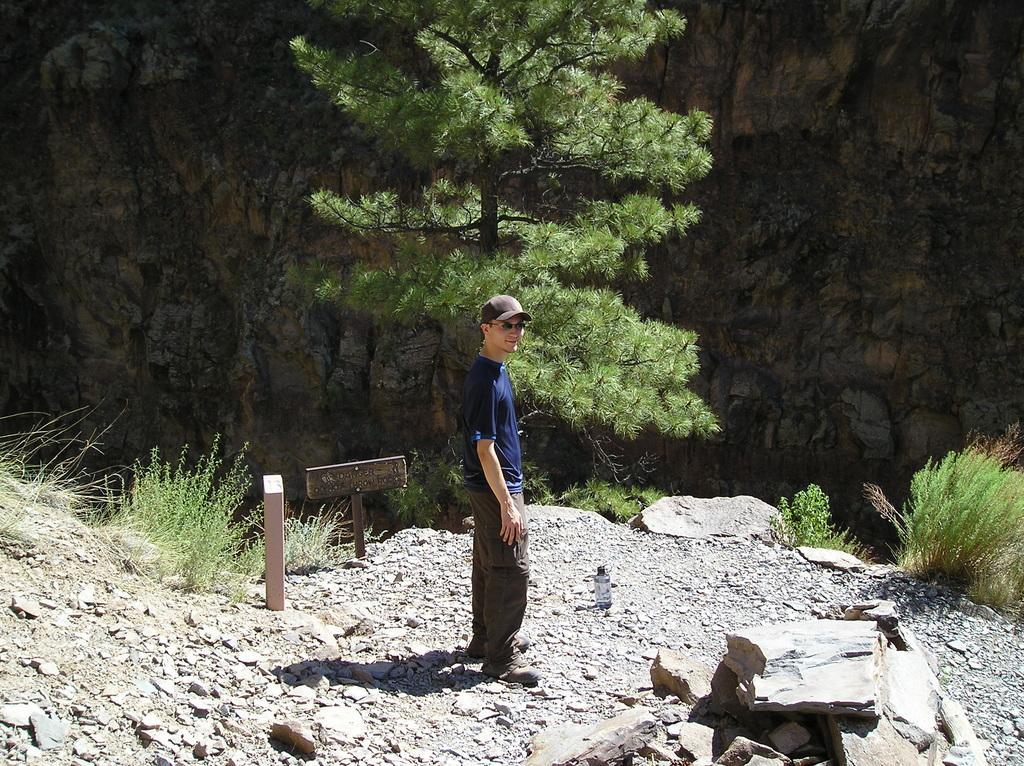Please provide a concise description of this image. In this image there is a person wearing a cap is standing on the surface of rocks with a smile on his face, behind the person there are trees and rocks. 